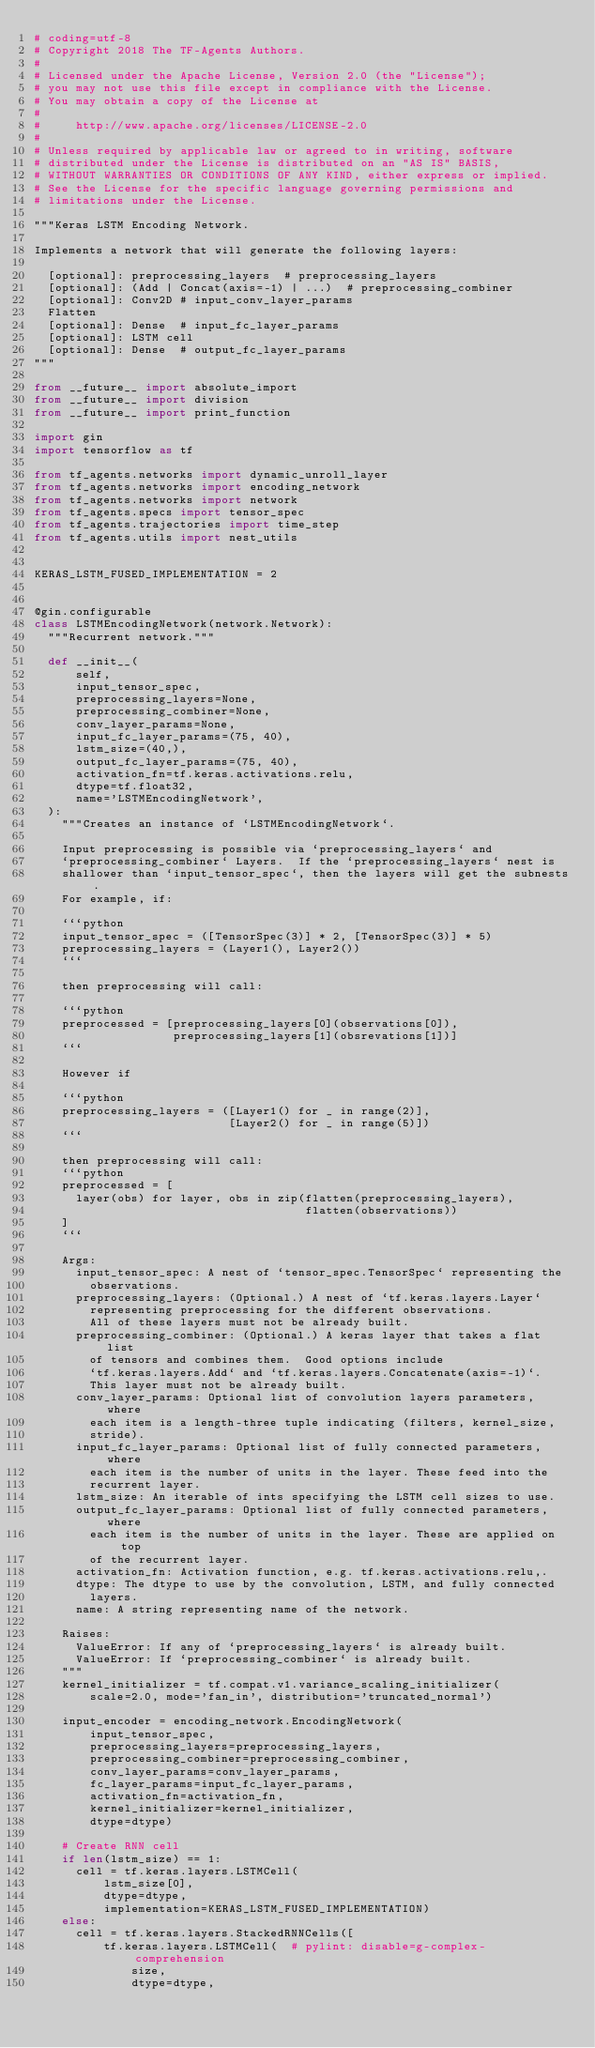Convert code to text. <code><loc_0><loc_0><loc_500><loc_500><_Python_># coding=utf-8
# Copyright 2018 The TF-Agents Authors.
#
# Licensed under the Apache License, Version 2.0 (the "License");
# you may not use this file except in compliance with the License.
# You may obtain a copy of the License at
#
#     http://www.apache.org/licenses/LICENSE-2.0
#
# Unless required by applicable law or agreed to in writing, software
# distributed under the License is distributed on an "AS IS" BASIS,
# WITHOUT WARRANTIES OR CONDITIONS OF ANY KIND, either express or implied.
# See the License for the specific language governing permissions and
# limitations under the License.

"""Keras LSTM Encoding Network.

Implements a network that will generate the following layers:

  [optional]: preprocessing_layers  # preprocessing_layers
  [optional]: (Add | Concat(axis=-1) | ...)  # preprocessing_combiner
  [optional]: Conv2D # input_conv_layer_params
  Flatten
  [optional]: Dense  # input_fc_layer_params
  [optional]: LSTM cell
  [optional]: Dense  # output_fc_layer_params
"""

from __future__ import absolute_import
from __future__ import division
from __future__ import print_function

import gin
import tensorflow as tf

from tf_agents.networks import dynamic_unroll_layer
from tf_agents.networks import encoding_network
from tf_agents.networks import network
from tf_agents.specs import tensor_spec
from tf_agents.trajectories import time_step
from tf_agents.utils import nest_utils


KERAS_LSTM_FUSED_IMPLEMENTATION = 2


@gin.configurable
class LSTMEncodingNetwork(network.Network):
  """Recurrent network."""

  def __init__(
      self,
      input_tensor_spec,
      preprocessing_layers=None,
      preprocessing_combiner=None,
      conv_layer_params=None,
      input_fc_layer_params=(75, 40),
      lstm_size=(40,),
      output_fc_layer_params=(75, 40),
      activation_fn=tf.keras.activations.relu,
      dtype=tf.float32,
      name='LSTMEncodingNetwork',
  ):
    """Creates an instance of `LSTMEncodingNetwork`.

    Input preprocessing is possible via `preprocessing_layers` and
    `preprocessing_combiner` Layers.  If the `preprocessing_layers` nest is
    shallower than `input_tensor_spec`, then the layers will get the subnests.
    For example, if:

    ```python
    input_tensor_spec = ([TensorSpec(3)] * 2, [TensorSpec(3)] * 5)
    preprocessing_layers = (Layer1(), Layer2())
    ```

    then preprocessing will call:

    ```python
    preprocessed = [preprocessing_layers[0](observations[0]),
                    preprocessing_layers[1](obsrevations[1])]
    ```

    However if

    ```python
    preprocessing_layers = ([Layer1() for _ in range(2)],
                            [Layer2() for _ in range(5)])
    ```

    then preprocessing will call:
    ```python
    preprocessed = [
      layer(obs) for layer, obs in zip(flatten(preprocessing_layers),
                                       flatten(observations))
    ]
    ```

    Args:
      input_tensor_spec: A nest of `tensor_spec.TensorSpec` representing the
        observations.
      preprocessing_layers: (Optional.) A nest of `tf.keras.layers.Layer`
        representing preprocessing for the different observations.
        All of these layers must not be already built.
      preprocessing_combiner: (Optional.) A keras layer that takes a flat list
        of tensors and combines them.  Good options include
        `tf.keras.layers.Add` and `tf.keras.layers.Concatenate(axis=-1)`.
        This layer must not be already built.
      conv_layer_params: Optional list of convolution layers parameters, where
        each item is a length-three tuple indicating (filters, kernel_size,
        stride).
      input_fc_layer_params: Optional list of fully connected parameters, where
        each item is the number of units in the layer. These feed into the
        recurrent layer.
      lstm_size: An iterable of ints specifying the LSTM cell sizes to use.
      output_fc_layer_params: Optional list of fully connected parameters, where
        each item is the number of units in the layer. These are applied on top
        of the recurrent layer.
      activation_fn: Activation function, e.g. tf.keras.activations.relu,.
      dtype: The dtype to use by the convolution, LSTM, and fully connected
        layers.
      name: A string representing name of the network.

    Raises:
      ValueError: If any of `preprocessing_layers` is already built.
      ValueError: If `preprocessing_combiner` is already built.
    """
    kernel_initializer = tf.compat.v1.variance_scaling_initializer(
        scale=2.0, mode='fan_in', distribution='truncated_normal')

    input_encoder = encoding_network.EncodingNetwork(
        input_tensor_spec,
        preprocessing_layers=preprocessing_layers,
        preprocessing_combiner=preprocessing_combiner,
        conv_layer_params=conv_layer_params,
        fc_layer_params=input_fc_layer_params,
        activation_fn=activation_fn,
        kernel_initializer=kernel_initializer,
        dtype=dtype)

    # Create RNN cell
    if len(lstm_size) == 1:
      cell = tf.keras.layers.LSTMCell(
          lstm_size[0],
          dtype=dtype,
          implementation=KERAS_LSTM_FUSED_IMPLEMENTATION)
    else:
      cell = tf.keras.layers.StackedRNNCells([
          tf.keras.layers.LSTMCell(  # pylint: disable=g-complex-comprehension
              size,
              dtype=dtype,</code> 